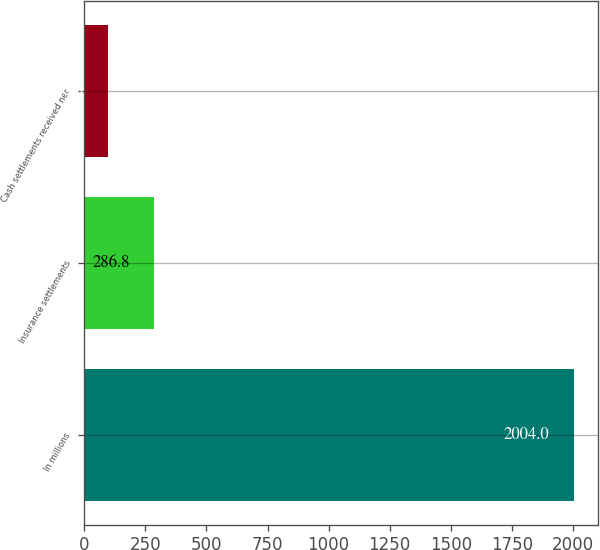<chart> <loc_0><loc_0><loc_500><loc_500><bar_chart><fcel>In millions<fcel>Insurance settlements<fcel>Cash settlements received net<nl><fcel>2004<fcel>286.8<fcel>96<nl></chart> 